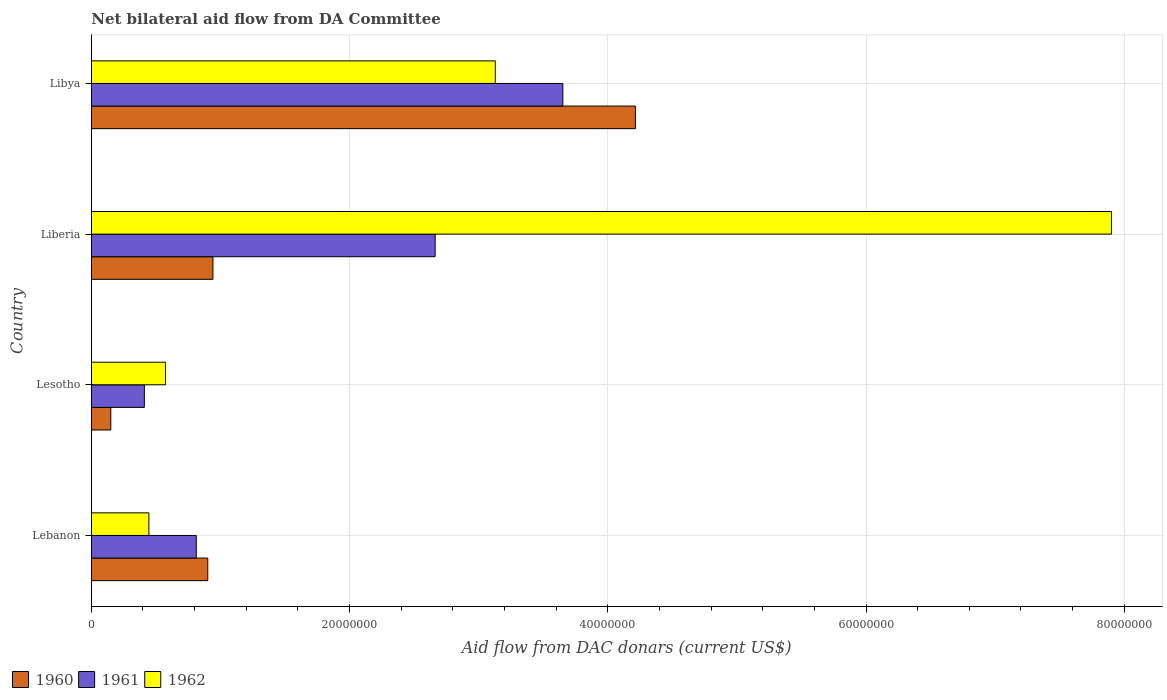How many groups of bars are there?
Provide a succinct answer. 4. Are the number of bars on each tick of the Y-axis equal?
Give a very brief answer. Yes. How many bars are there on the 4th tick from the bottom?
Keep it short and to the point. 3. What is the label of the 2nd group of bars from the top?
Ensure brevity in your answer.  Liberia. What is the aid flow in in 1961 in Libya?
Your response must be concise. 3.65e+07. Across all countries, what is the maximum aid flow in in 1960?
Provide a succinct answer. 4.21e+07. Across all countries, what is the minimum aid flow in in 1960?
Your answer should be compact. 1.51e+06. In which country was the aid flow in in 1960 maximum?
Your answer should be compact. Libya. In which country was the aid flow in in 1960 minimum?
Keep it short and to the point. Lesotho. What is the total aid flow in in 1960 in the graph?
Offer a very short reply. 6.21e+07. What is the difference between the aid flow in in 1961 in Lesotho and that in Liberia?
Provide a succinct answer. -2.25e+07. What is the difference between the aid flow in in 1961 in Lesotho and the aid flow in in 1962 in Lebanon?
Give a very brief answer. -3.50e+05. What is the average aid flow in in 1962 per country?
Make the answer very short. 3.01e+07. What is the difference between the aid flow in in 1961 and aid flow in in 1960 in Lebanon?
Give a very brief answer. -8.90e+05. In how many countries, is the aid flow in in 1962 greater than 76000000 US$?
Ensure brevity in your answer.  1. What is the ratio of the aid flow in in 1962 in Lebanon to that in Libya?
Offer a terse response. 0.14. Is the aid flow in in 1960 in Lesotho less than that in Libya?
Offer a terse response. Yes. Is the difference between the aid flow in in 1961 in Liberia and Libya greater than the difference between the aid flow in in 1960 in Liberia and Libya?
Offer a very short reply. Yes. What is the difference between the highest and the second highest aid flow in in 1960?
Your response must be concise. 3.27e+07. What is the difference between the highest and the lowest aid flow in in 1962?
Your answer should be compact. 7.46e+07. In how many countries, is the aid flow in in 1962 greater than the average aid flow in in 1962 taken over all countries?
Your response must be concise. 2. Are all the bars in the graph horizontal?
Your answer should be very brief. Yes. How many countries are there in the graph?
Give a very brief answer. 4. What is the difference between two consecutive major ticks on the X-axis?
Your answer should be very brief. 2.00e+07. Are the values on the major ticks of X-axis written in scientific E-notation?
Make the answer very short. No. Does the graph contain any zero values?
Provide a succinct answer. No. What is the title of the graph?
Give a very brief answer. Net bilateral aid flow from DA Committee. What is the label or title of the X-axis?
Your answer should be very brief. Aid flow from DAC donars (current US$). What is the Aid flow from DAC donars (current US$) in 1960 in Lebanon?
Provide a short and direct response. 9.02e+06. What is the Aid flow from DAC donars (current US$) in 1961 in Lebanon?
Your answer should be very brief. 8.13e+06. What is the Aid flow from DAC donars (current US$) in 1962 in Lebanon?
Provide a succinct answer. 4.46e+06. What is the Aid flow from DAC donars (current US$) in 1960 in Lesotho?
Offer a terse response. 1.51e+06. What is the Aid flow from DAC donars (current US$) in 1961 in Lesotho?
Keep it short and to the point. 4.11e+06. What is the Aid flow from DAC donars (current US$) in 1962 in Lesotho?
Provide a short and direct response. 5.75e+06. What is the Aid flow from DAC donars (current US$) of 1960 in Liberia?
Provide a succinct answer. 9.42e+06. What is the Aid flow from DAC donars (current US$) in 1961 in Liberia?
Your answer should be very brief. 2.66e+07. What is the Aid flow from DAC donars (current US$) of 1962 in Liberia?
Your response must be concise. 7.90e+07. What is the Aid flow from DAC donars (current US$) in 1960 in Libya?
Keep it short and to the point. 4.21e+07. What is the Aid flow from DAC donars (current US$) in 1961 in Libya?
Keep it short and to the point. 3.65e+07. What is the Aid flow from DAC donars (current US$) of 1962 in Libya?
Your answer should be very brief. 3.13e+07. Across all countries, what is the maximum Aid flow from DAC donars (current US$) of 1960?
Ensure brevity in your answer.  4.21e+07. Across all countries, what is the maximum Aid flow from DAC donars (current US$) in 1961?
Your answer should be compact. 3.65e+07. Across all countries, what is the maximum Aid flow from DAC donars (current US$) in 1962?
Keep it short and to the point. 7.90e+07. Across all countries, what is the minimum Aid flow from DAC donars (current US$) of 1960?
Provide a short and direct response. 1.51e+06. Across all countries, what is the minimum Aid flow from DAC donars (current US$) of 1961?
Keep it short and to the point. 4.11e+06. Across all countries, what is the minimum Aid flow from DAC donars (current US$) of 1962?
Provide a short and direct response. 4.46e+06. What is the total Aid flow from DAC donars (current US$) in 1960 in the graph?
Provide a short and direct response. 6.21e+07. What is the total Aid flow from DAC donars (current US$) of 1961 in the graph?
Make the answer very short. 7.54e+07. What is the total Aid flow from DAC donars (current US$) in 1962 in the graph?
Your answer should be compact. 1.21e+08. What is the difference between the Aid flow from DAC donars (current US$) in 1960 in Lebanon and that in Lesotho?
Make the answer very short. 7.51e+06. What is the difference between the Aid flow from DAC donars (current US$) of 1961 in Lebanon and that in Lesotho?
Offer a terse response. 4.02e+06. What is the difference between the Aid flow from DAC donars (current US$) of 1962 in Lebanon and that in Lesotho?
Make the answer very short. -1.29e+06. What is the difference between the Aid flow from DAC donars (current US$) in 1960 in Lebanon and that in Liberia?
Your answer should be compact. -4.00e+05. What is the difference between the Aid flow from DAC donars (current US$) in 1961 in Lebanon and that in Liberia?
Offer a very short reply. -1.85e+07. What is the difference between the Aid flow from DAC donars (current US$) of 1962 in Lebanon and that in Liberia?
Provide a short and direct response. -7.46e+07. What is the difference between the Aid flow from DAC donars (current US$) in 1960 in Lebanon and that in Libya?
Keep it short and to the point. -3.31e+07. What is the difference between the Aid flow from DAC donars (current US$) in 1961 in Lebanon and that in Libya?
Ensure brevity in your answer.  -2.84e+07. What is the difference between the Aid flow from DAC donars (current US$) of 1962 in Lebanon and that in Libya?
Offer a terse response. -2.68e+07. What is the difference between the Aid flow from DAC donars (current US$) of 1960 in Lesotho and that in Liberia?
Your answer should be compact. -7.91e+06. What is the difference between the Aid flow from DAC donars (current US$) of 1961 in Lesotho and that in Liberia?
Provide a short and direct response. -2.25e+07. What is the difference between the Aid flow from DAC donars (current US$) in 1962 in Lesotho and that in Liberia?
Give a very brief answer. -7.33e+07. What is the difference between the Aid flow from DAC donars (current US$) in 1960 in Lesotho and that in Libya?
Give a very brief answer. -4.06e+07. What is the difference between the Aid flow from DAC donars (current US$) of 1961 in Lesotho and that in Libya?
Your answer should be very brief. -3.24e+07. What is the difference between the Aid flow from DAC donars (current US$) in 1962 in Lesotho and that in Libya?
Ensure brevity in your answer.  -2.55e+07. What is the difference between the Aid flow from DAC donars (current US$) in 1960 in Liberia and that in Libya?
Your response must be concise. -3.27e+07. What is the difference between the Aid flow from DAC donars (current US$) in 1961 in Liberia and that in Libya?
Offer a very short reply. -9.89e+06. What is the difference between the Aid flow from DAC donars (current US$) of 1962 in Liberia and that in Libya?
Your response must be concise. 4.77e+07. What is the difference between the Aid flow from DAC donars (current US$) of 1960 in Lebanon and the Aid flow from DAC donars (current US$) of 1961 in Lesotho?
Offer a terse response. 4.91e+06. What is the difference between the Aid flow from DAC donars (current US$) in 1960 in Lebanon and the Aid flow from DAC donars (current US$) in 1962 in Lesotho?
Provide a succinct answer. 3.27e+06. What is the difference between the Aid flow from DAC donars (current US$) of 1961 in Lebanon and the Aid flow from DAC donars (current US$) of 1962 in Lesotho?
Keep it short and to the point. 2.38e+06. What is the difference between the Aid flow from DAC donars (current US$) in 1960 in Lebanon and the Aid flow from DAC donars (current US$) in 1961 in Liberia?
Give a very brief answer. -1.76e+07. What is the difference between the Aid flow from DAC donars (current US$) of 1960 in Lebanon and the Aid flow from DAC donars (current US$) of 1962 in Liberia?
Offer a very short reply. -7.00e+07. What is the difference between the Aid flow from DAC donars (current US$) in 1961 in Lebanon and the Aid flow from DAC donars (current US$) in 1962 in Liberia?
Your answer should be compact. -7.09e+07. What is the difference between the Aid flow from DAC donars (current US$) in 1960 in Lebanon and the Aid flow from DAC donars (current US$) in 1961 in Libya?
Make the answer very short. -2.75e+07. What is the difference between the Aid flow from DAC donars (current US$) in 1960 in Lebanon and the Aid flow from DAC donars (current US$) in 1962 in Libya?
Keep it short and to the point. -2.23e+07. What is the difference between the Aid flow from DAC donars (current US$) of 1961 in Lebanon and the Aid flow from DAC donars (current US$) of 1962 in Libya?
Your answer should be very brief. -2.32e+07. What is the difference between the Aid flow from DAC donars (current US$) of 1960 in Lesotho and the Aid flow from DAC donars (current US$) of 1961 in Liberia?
Offer a terse response. -2.51e+07. What is the difference between the Aid flow from DAC donars (current US$) in 1960 in Lesotho and the Aid flow from DAC donars (current US$) in 1962 in Liberia?
Provide a short and direct response. -7.75e+07. What is the difference between the Aid flow from DAC donars (current US$) of 1961 in Lesotho and the Aid flow from DAC donars (current US$) of 1962 in Liberia?
Provide a short and direct response. -7.49e+07. What is the difference between the Aid flow from DAC donars (current US$) in 1960 in Lesotho and the Aid flow from DAC donars (current US$) in 1961 in Libya?
Make the answer very short. -3.50e+07. What is the difference between the Aid flow from DAC donars (current US$) in 1960 in Lesotho and the Aid flow from DAC donars (current US$) in 1962 in Libya?
Your answer should be very brief. -2.98e+07. What is the difference between the Aid flow from DAC donars (current US$) of 1961 in Lesotho and the Aid flow from DAC donars (current US$) of 1962 in Libya?
Offer a terse response. -2.72e+07. What is the difference between the Aid flow from DAC donars (current US$) in 1960 in Liberia and the Aid flow from DAC donars (current US$) in 1961 in Libya?
Your response must be concise. -2.71e+07. What is the difference between the Aid flow from DAC donars (current US$) of 1960 in Liberia and the Aid flow from DAC donars (current US$) of 1962 in Libya?
Your answer should be compact. -2.19e+07. What is the difference between the Aid flow from DAC donars (current US$) in 1961 in Liberia and the Aid flow from DAC donars (current US$) in 1962 in Libya?
Ensure brevity in your answer.  -4.66e+06. What is the average Aid flow from DAC donars (current US$) of 1960 per country?
Your response must be concise. 1.55e+07. What is the average Aid flow from DAC donars (current US$) in 1961 per country?
Your response must be concise. 1.88e+07. What is the average Aid flow from DAC donars (current US$) in 1962 per country?
Provide a short and direct response. 3.01e+07. What is the difference between the Aid flow from DAC donars (current US$) in 1960 and Aid flow from DAC donars (current US$) in 1961 in Lebanon?
Offer a very short reply. 8.90e+05. What is the difference between the Aid flow from DAC donars (current US$) of 1960 and Aid flow from DAC donars (current US$) of 1962 in Lebanon?
Offer a very short reply. 4.56e+06. What is the difference between the Aid flow from DAC donars (current US$) of 1961 and Aid flow from DAC donars (current US$) of 1962 in Lebanon?
Ensure brevity in your answer.  3.67e+06. What is the difference between the Aid flow from DAC donars (current US$) of 1960 and Aid flow from DAC donars (current US$) of 1961 in Lesotho?
Ensure brevity in your answer.  -2.60e+06. What is the difference between the Aid flow from DAC donars (current US$) of 1960 and Aid flow from DAC donars (current US$) of 1962 in Lesotho?
Make the answer very short. -4.24e+06. What is the difference between the Aid flow from DAC donars (current US$) of 1961 and Aid flow from DAC donars (current US$) of 1962 in Lesotho?
Offer a terse response. -1.64e+06. What is the difference between the Aid flow from DAC donars (current US$) of 1960 and Aid flow from DAC donars (current US$) of 1961 in Liberia?
Keep it short and to the point. -1.72e+07. What is the difference between the Aid flow from DAC donars (current US$) in 1960 and Aid flow from DAC donars (current US$) in 1962 in Liberia?
Provide a succinct answer. -6.96e+07. What is the difference between the Aid flow from DAC donars (current US$) in 1961 and Aid flow from DAC donars (current US$) in 1962 in Liberia?
Give a very brief answer. -5.24e+07. What is the difference between the Aid flow from DAC donars (current US$) of 1960 and Aid flow from DAC donars (current US$) of 1961 in Libya?
Give a very brief answer. 5.62e+06. What is the difference between the Aid flow from DAC donars (current US$) of 1960 and Aid flow from DAC donars (current US$) of 1962 in Libya?
Make the answer very short. 1.08e+07. What is the difference between the Aid flow from DAC donars (current US$) of 1961 and Aid flow from DAC donars (current US$) of 1962 in Libya?
Your answer should be very brief. 5.23e+06. What is the ratio of the Aid flow from DAC donars (current US$) in 1960 in Lebanon to that in Lesotho?
Your response must be concise. 5.97. What is the ratio of the Aid flow from DAC donars (current US$) in 1961 in Lebanon to that in Lesotho?
Provide a short and direct response. 1.98. What is the ratio of the Aid flow from DAC donars (current US$) of 1962 in Lebanon to that in Lesotho?
Provide a short and direct response. 0.78. What is the ratio of the Aid flow from DAC donars (current US$) of 1960 in Lebanon to that in Liberia?
Provide a short and direct response. 0.96. What is the ratio of the Aid flow from DAC donars (current US$) of 1961 in Lebanon to that in Liberia?
Your response must be concise. 0.31. What is the ratio of the Aid flow from DAC donars (current US$) of 1962 in Lebanon to that in Liberia?
Make the answer very short. 0.06. What is the ratio of the Aid flow from DAC donars (current US$) of 1960 in Lebanon to that in Libya?
Your answer should be very brief. 0.21. What is the ratio of the Aid flow from DAC donars (current US$) of 1961 in Lebanon to that in Libya?
Keep it short and to the point. 0.22. What is the ratio of the Aid flow from DAC donars (current US$) in 1962 in Lebanon to that in Libya?
Ensure brevity in your answer.  0.14. What is the ratio of the Aid flow from DAC donars (current US$) of 1960 in Lesotho to that in Liberia?
Offer a terse response. 0.16. What is the ratio of the Aid flow from DAC donars (current US$) in 1961 in Lesotho to that in Liberia?
Offer a very short reply. 0.15. What is the ratio of the Aid flow from DAC donars (current US$) in 1962 in Lesotho to that in Liberia?
Provide a short and direct response. 0.07. What is the ratio of the Aid flow from DAC donars (current US$) in 1960 in Lesotho to that in Libya?
Offer a very short reply. 0.04. What is the ratio of the Aid flow from DAC donars (current US$) of 1961 in Lesotho to that in Libya?
Your response must be concise. 0.11. What is the ratio of the Aid flow from DAC donars (current US$) in 1962 in Lesotho to that in Libya?
Your answer should be very brief. 0.18. What is the ratio of the Aid flow from DAC donars (current US$) of 1960 in Liberia to that in Libya?
Your response must be concise. 0.22. What is the ratio of the Aid flow from DAC donars (current US$) of 1961 in Liberia to that in Libya?
Keep it short and to the point. 0.73. What is the ratio of the Aid flow from DAC donars (current US$) in 1962 in Liberia to that in Libya?
Provide a short and direct response. 2.53. What is the difference between the highest and the second highest Aid flow from DAC donars (current US$) in 1960?
Offer a terse response. 3.27e+07. What is the difference between the highest and the second highest Aid flow from DAC donars (current US$) in 1961?
Give a very brief answer. 9.89e+06. What is the difference between the highest and the second highest Aid flow from DAC donars (current US$) of 1962?
Provide a short and direct response. 4.77e+07. What is the difference between the highest and the lowest Aid flow from DAC donars (current US$) in 1960?
Make the answer very short. 4.06e+07. What is the difference between the highest and the lowest Aid flow from DAC donars (current US$) in 1961?
Your answer should be compact. 3.24e+07. What is the difference between the highest and the lowest Aid flow from DAC donars (current US$) of 1962?
Offer a very short reply. 7.46e+07. 